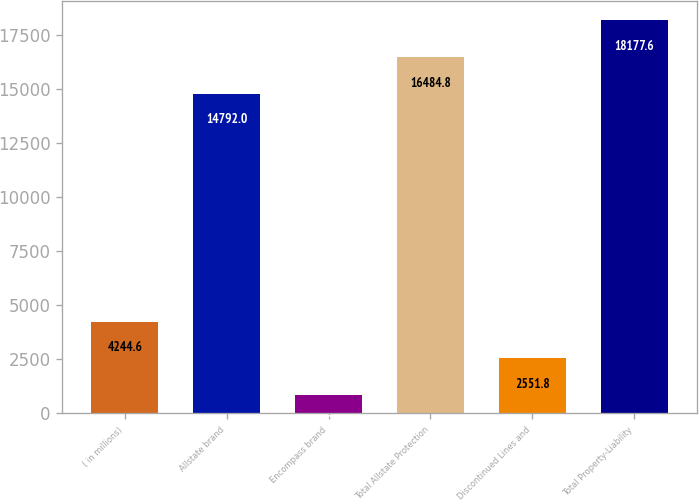Convert chart to OTSL. <chart><loc_0><loc_0><loc_500><loc_500><bar_chart><fcel>( in millions)<fcel>Allstate brand<fcel>Encompass brand<fcel>Total Allstate Protection<fcel>Discontinued Lines and<fcel>Total Property-Liability<nl><fcel>4244.6<fcel>14792<fcel>859<fcel>16484.8<fcel>2551.8<fcel>18177.6<nl></chart> 